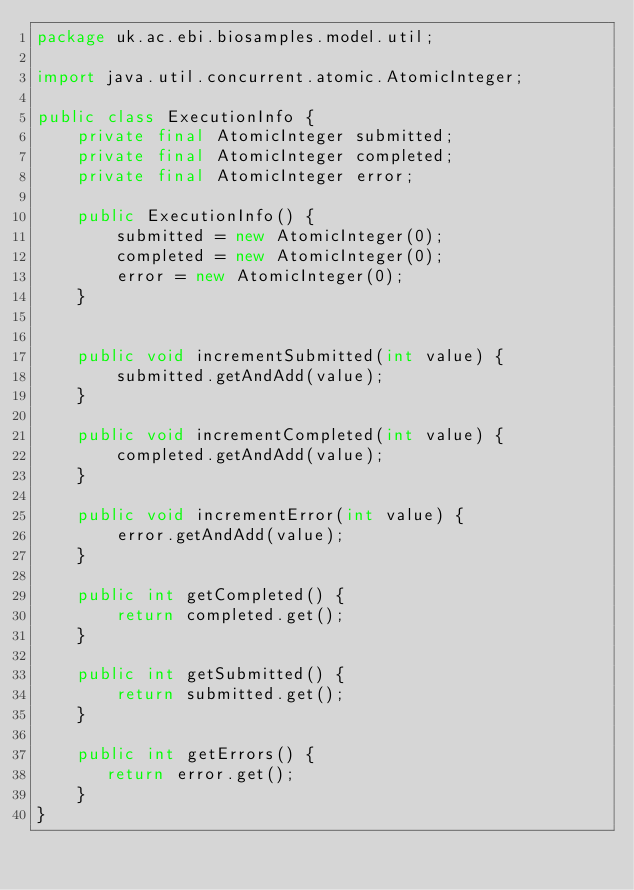<code> <loc_0><loc_0><loc_500><loc_500><_Java_>package uk.ac.ebi.biosamples.model.util;

import java.util.concurrent.atomic.AtomicInteger;

public class ExecutionInfo {
    private final AtomicInteger submitted;
    private final AtomicInteger completed;
    private final AtomicInteger error;

    public ExecutionInfo() {
        submitted = new AtomicInteger(0);
        completed = new AtomicInteger(0);
        error = new AtomicInteger(0);
    }


    public void incrementSubmitted(int value) {
        submitted.getAndAdd(value);
    }

    public void incrementCompleted(int value) {
        completed.getAndAdd(value);
    }

    public void incrementError(int value) {
        error.getAndAdd(value);
    }

    public int getCompleted() {
        return completed.get();
    }

    public int getSubmitted() {
        return submitted.get();
    }

    public int getErrors() {
       return error.get();
    }
}
</code> 